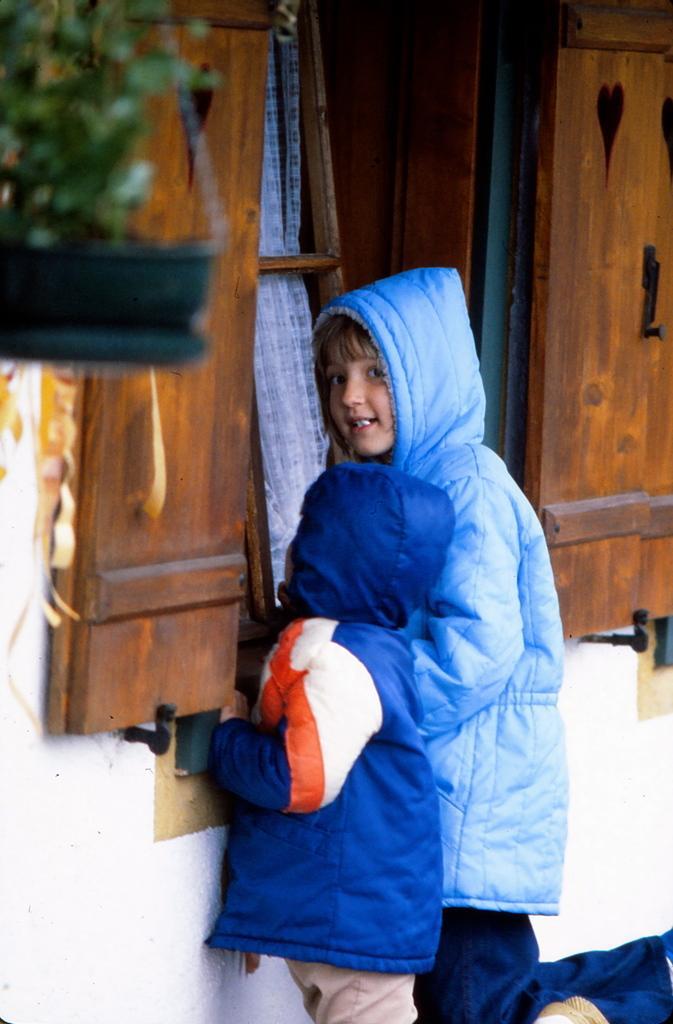Describe this image in one or two sentences. In this image we can see the kids wearing their jackets. We can also see the wall, wooden window and also the curtain. We can also see the flower pot. 